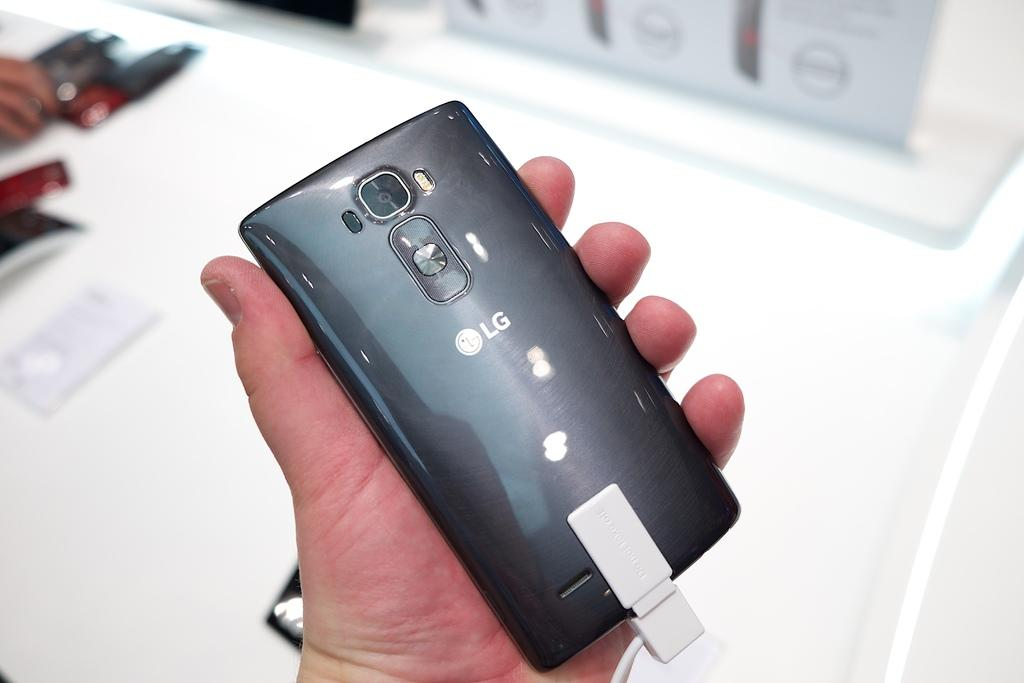<image>
Describe the image concisely. A person holding a LG phone in their left hand. 